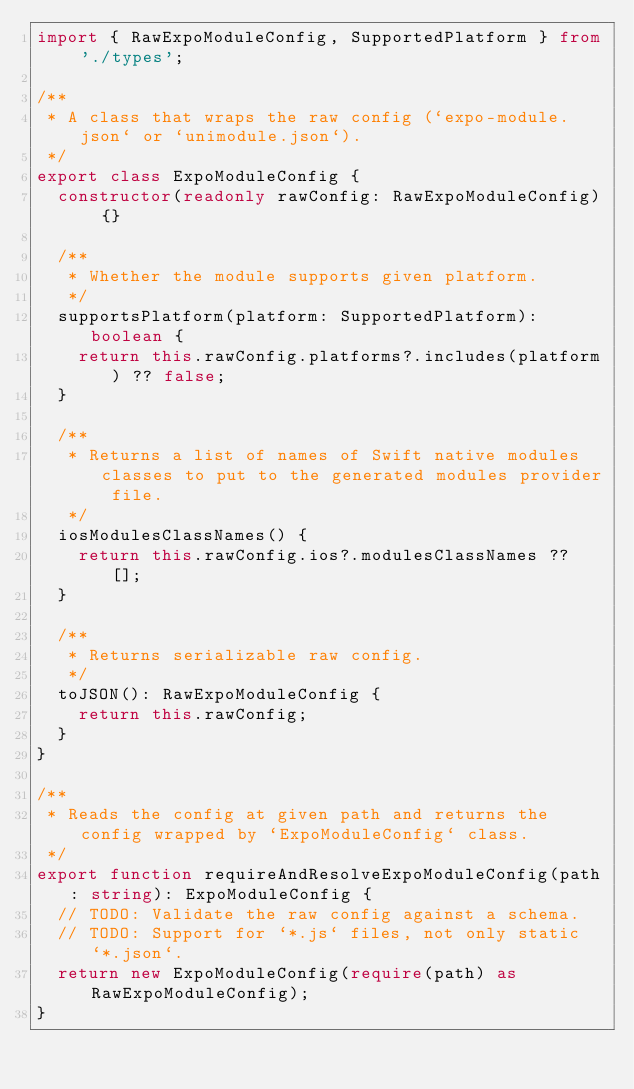Convert code to text. <code><loc_0><loc_0><loc_500><loc_500><_TypeScript_>import { RawExpoModuleConfig, SupportedPlatform } from './types';

/**
 * A class that wraps the raw config (`expo-module.json` or `unimodule.json`).
 */
export class ExpoModuleConfig {
  constructor(readonly rawConfig: RawExpoModuleConfig) {}

  /**
   * Whether the module supports given platform.
   */
  supportsPlatform(platform: SupportedPlatform): boolean {
    return this.rawConfig.platforms?.includes(platform) ?? false;
  }

  /**
   * Returns a list of names of Swift native modules classes to put to the generated modules provider file.
   */
  iosModulesClassNames() {
    return this.rawConfig.ios?.modulesClassNames ?? [];
  }

  /**
   * Returns serializable raw config.
   */
  toJSON(): RawExpoModuleConfig {
    return this.rawConfig;
  }
}

/**
 * Reads the config at given path and returns the config wrapped by `ExpoModuleConfig` class.
 */
export function requireAndResolveExpoModuleConfig(path: string): ExpoModuleConfig {
  // TODO: Validate the raw config against a schema.
  // TODO: Support for `*.js` files, not only static `*.json`.
  return new ExpoModuleConfig(require(path) as RawExpoModuleConfig);
}
</code> 